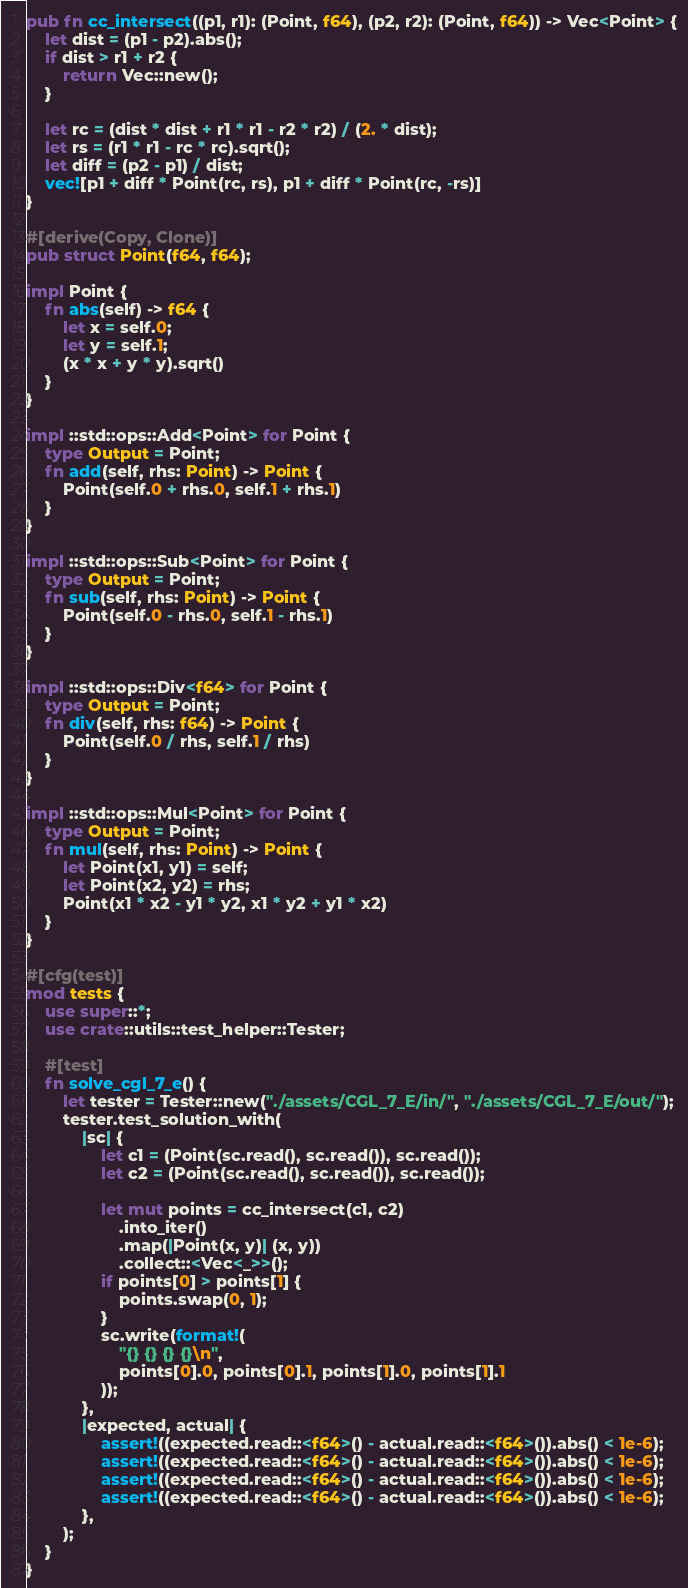<code> <loc_0><loc_0><loc_500><loc_500><_Rust_>pub fn cc_intersect((p1, r1): (Point, f64), (p2, r2): (Point, f64)) -> Vec<Point> {
    let dist = (p1 - p2).abs();
    if dist > r1 + r2 {
        return Vec::new();
    }

    let rc = (dist * dist + r1 * r1 - r2 * r2) / (2. * dist);
    let rs = (r1 * r1 - rc * rc).sqrt();
    let diff = (p2 - p1) / dist;
    vec![p1 + diff * Point(rc, rs), p1 + diff * Point(rc, -rs)]
}

#[derive(Copy, Clone)]
pub struct Point(f64, f64);

impl Point {
    fn abs(self) -> f64 {
        let x = self.0;
        let y = self.1;
        (x * x + y * y).sqrt()
    }
}

impl ::std::ops::Add<Point> for Point {
    type Output = Point;
    fn add(self, rhs: Point) -> Point {
        Point(self.0 + rhs.0, self.1 + rhs.1)
    }
}

impl ::std::ops::Sub<Point> for Point {
    type Output = Point;
    fn sub(self, rhs: Point) -> Point {
        Point(self.0 - rhs.0, self.1 - rhs.1)
    }
}

impl ::std::ops::Div<f64> for Point {
    type Output = Point;
    fn div(self, rhs: f64) -> Point {
        Point(self.0 / rhs, self.1 / rhs)
    }
}

impl ::std::ops::Mul<Point> for Point {
    type Output = Point;
    fn mul(self, rhs: Point) -> Point {
        let Point(x1, y1) = self;
        let Point(x2, y2) = rhs;
        Point(x1 * x2 - y1 * y2, x1 * y2 + y1 * x2)
    }
}

#[cfg(test)]
mod tests {
    use super::*;
    use crate::utils::test_helper::Tester;

    #[test]
    fn solve_cgl_7_e() {
        let tester = Tester::new("./assets/CGL_7_E/in/", "./assets/CGL_7_E/out/");
        tester.test_solution_with(
            |sc| {
                let c1 = (Point(sc.read(), sc.read()), sc.read());
                let c2 = (Point(sc.read(), sc.read()), sc.read());

                let mut points = cc_intersect(c1, c2)
                    .into_iter()
                    .map(|Point(x, y)| (x, y))
                    .collect::<Vec<_>>();
                if points[0] > points[1] {
                    points.swap(0, 1);
                }
                sc.write(format!(
                    "{} {} {} {}\n",
                    points[0].0, points[0].1, points[1].0, points[1].1
                ));
            },
            |expected, actual| {
                assert!((expected.read::<f64>() - actual.read::<f64>()).abs() < 1e-6);
                assert!((expected.read::<f64>() - actual.read::<f64>()).abs() < 1e-6);
                assert!((expected.read::<f64>() - actual.read::<f64>()).abs() < 1e-6);
                assert!((expected.read::<f64>() - actual.read::<f64>()).abs() < 1e-6);
            },
        );
    }
}
</code> 